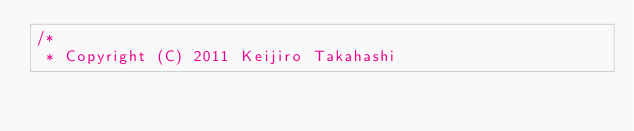Convert code to text. <code><loc_0><loc_0><loc_500><loc_500><_ObjectiveC_>/*
 * Copyright (C) 2011 Keijiro Takahashi</code> 